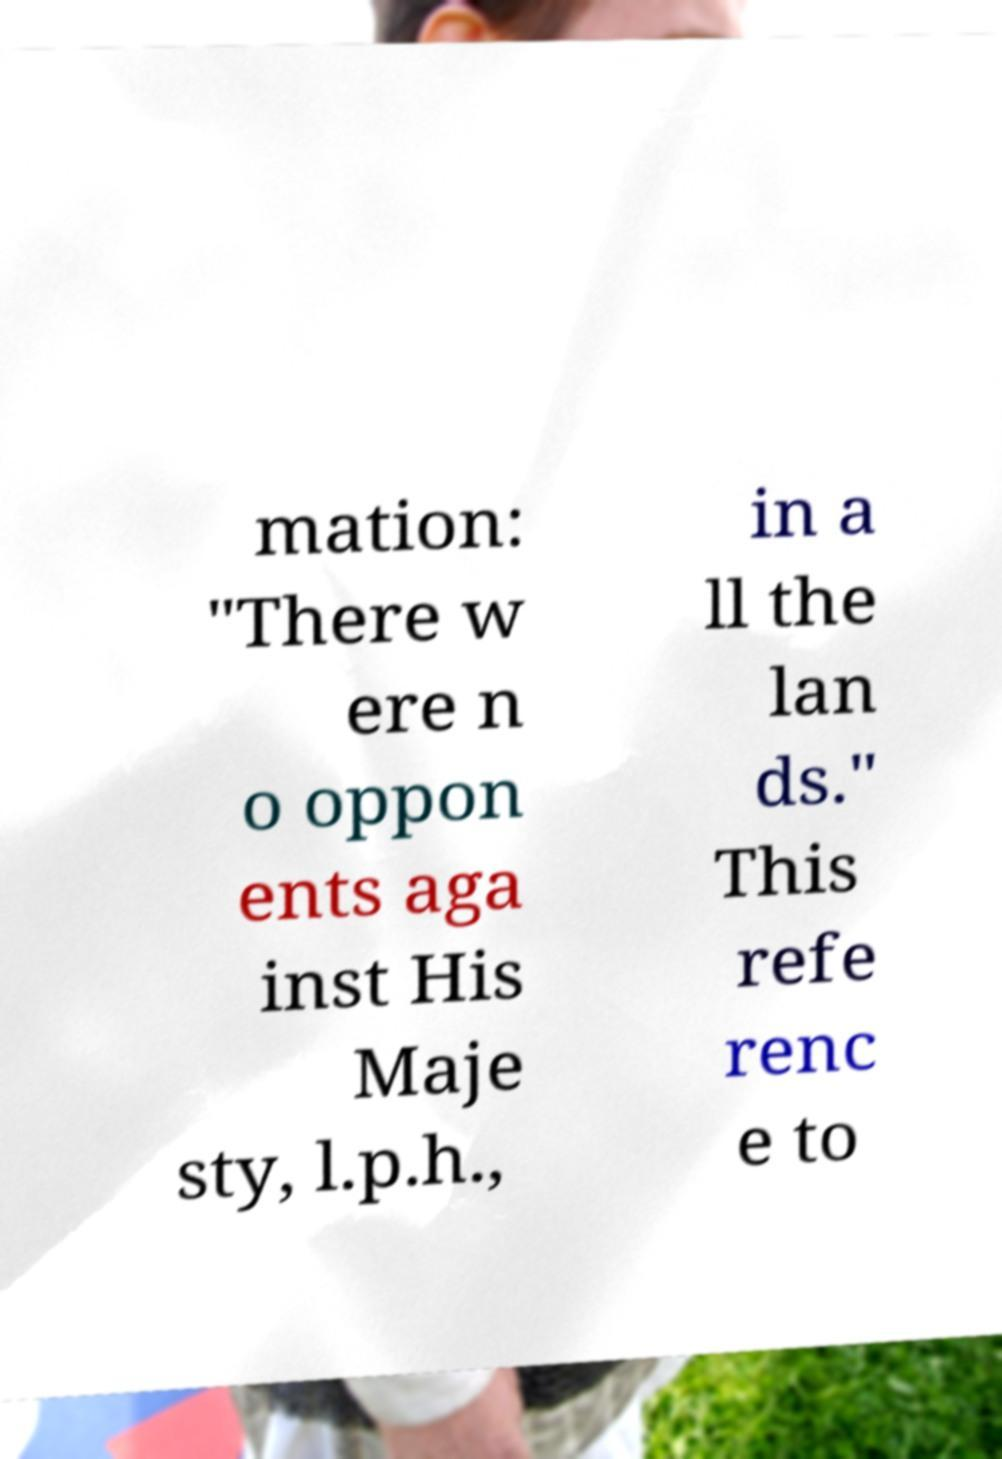Could you extract and type out the text from this image? mation: "There w ere n o oppon ents aga inst His Maje sty, l.p.h., in a ll the lan ds." This refe renc e to 